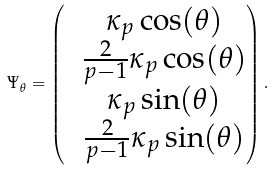<formula> <loc_0><loc_0><loc_500><loc_500>\Psi _ { \theta } = \begin{pmatrix} & \kappa _ { p } \cos ( \theta ) \\ & \frac { 2 } { p - 1 } \kappa _ { p } \cos ( \theta ) \\ & \kappa _ { p } \sin ( \theta ) \\ & \frac { 2 } { p - 1 } \kappa _ { p } \sin ( \theta ) \end{pmatrix} .</formula> 